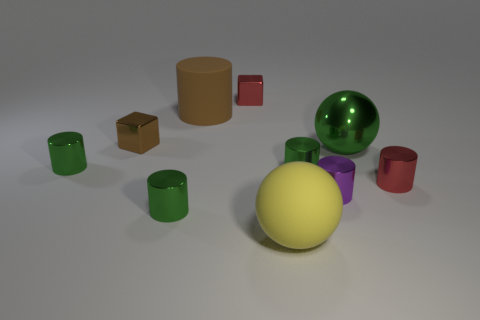There is a cube that is the same color as the large cylinder; what material is it?
Provide a succinct answer. Metal. How many other things are there of the same color as the large cylinder?
Give a very brief answer. 1. Do the rubber sphere and the block on the left side of the rubber cylinder have the same color?
Provide a short and direct response. No. Are there any tiny purple cylinders made of the same material as the yellow thing?
Ensure brevity in your answer.  No. What number of tiny red objects are there?
Offer a terse response. 2. What material is the large object that is behind the large shiny sphere that is on the right side of the small purple shiny object made of?
Your answer should be very brief. Rubber. There is a sphere that is made of the same material as the brown cylinder; what is its color?
Make the answer very short. Yellow. There is a small metal thing that is the same color as the big matte cylinder; what is its shape?
Provide a short and direct response. Cube. There is a green metallic cylinder on the left side of the tiny brown metallic thing; is it the same size as the green cylinder on the right side of the big yellow sphere?
Give a very brief answer. Yes. What number of cubes are either purple metallic objects or big yellow things?
Your answer should be compact. 0. 